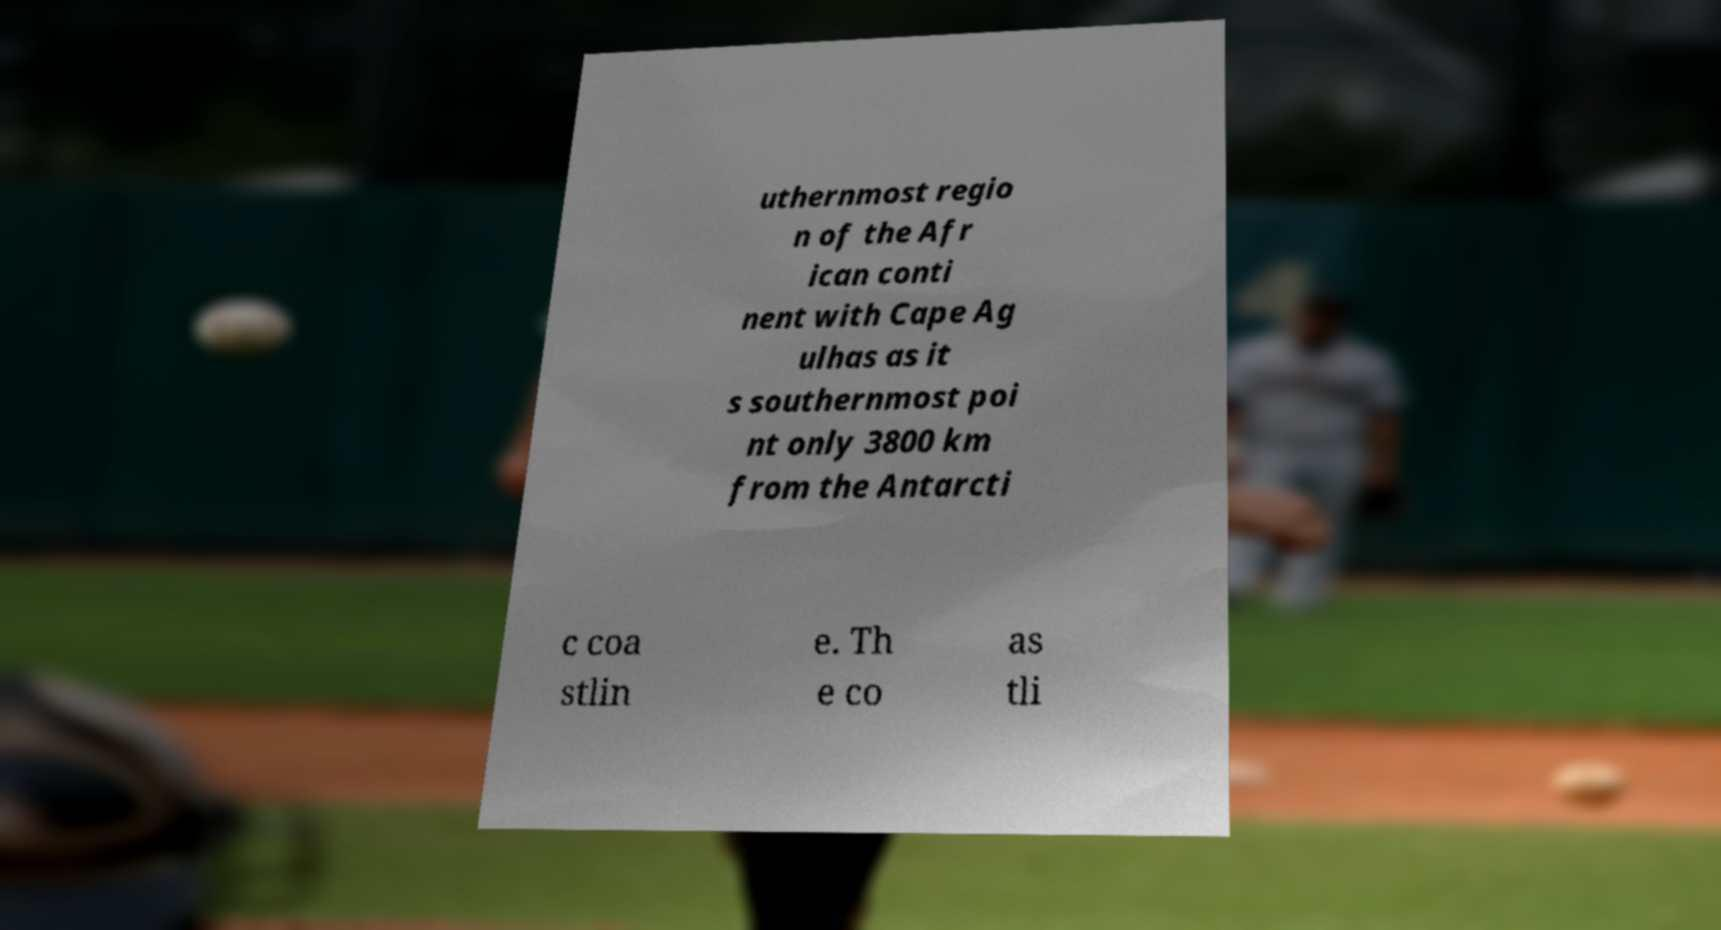I need the written content from this picture converted into text. Can you do that? uthernmost regio n of the Afr ican conti nent with Cape Ag ulhas as it s southernmost poi nt only 3800 km from the Antarcti c coa stlin e. Th e co as tli 